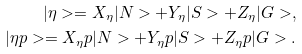<formula> <loc_0><loc_0><loc_500><loc_500>| \eta > = X _ { \eta } | N > + Y _ { \eta } | S > + Z _ { \eta } | G > , \\ | \eta p > = X _ { \eta } p | N > + Y _ { \eta } p | S > + Z _ { \eta } p | G > .</formula> 